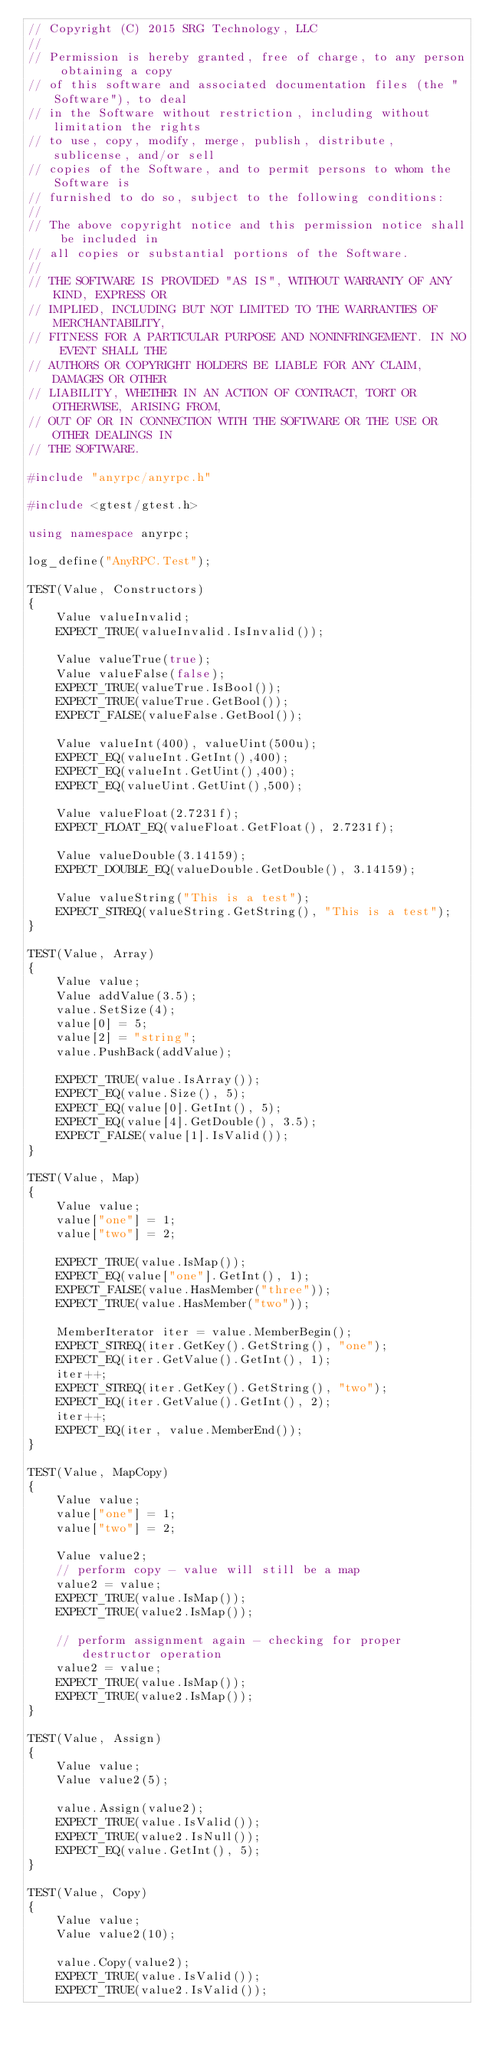Convert code to text. <code><loc_0><loc_0><loc_500><loc_500><_C++_>// Copyright (C) 2015 SRG Technology, LLC
//
// Permission is hereby granted, free of charge, to any person obtaining a copy
// of this software and associated documentation files (the "Software"), to deal
// in the Software without restriction, including without limitation the rights
// to use, copy, modify, merge, publish, distribute, sublicense, and/or sell
// copies of the Software, and to permit persons to whom the Software is
// furnished to do so, subject to the following conditions:
//
// The above copyright notice and this permission notice shall be included in
// all copies or substantial portions of the Software.
//
// THE SOFTWARE IS PROVIDED "AS IS", WITHOUT WARRANTY OF ANY KIND, EXPRESS OR
// IMPLIED, INCLUDING BUT NOT LIMITED TO THE WARRANTIES OF MERCHANTABILITY,
// FITNESS FOR A PARTICULAR PURPOSE AND NONINFRINGEMENT. IN NO EVENT SHALL THE
// AUTHORS OR COPYRIGHT HOLDERS BE LIABLE FOR ANY CLAIM, DAMAGES OR OTHER
// LIABILITY, WHETHER IN AN ACTION OF CONTRACT, TORT OR OTHERWISE, ARISING FROM,
// OUT OF OR IN CONNECTION WITH THE SOFTWARE OR THE USE OR OTHER DEALINGS IN
// THE SOFTWARE.

#include "anyrpc/anyrpc.h"

#include <gtest/gtest.h>

using namespace anyrpc;

log_define("AnyRPC.Test");

TEST(Value, Constructors)
{
    Value valueInvalid;
    EXPECT_TRUE(valueInvalid.IsInvalid());

    Value valueTrue(true);
    Value valueFalse(false);
    EXPECT_TRUE(valueTrue.IsBool());
    EXPECT_TRUE(valueTrue.GetBool());
    EXPECT_FALSE(valueFalse.GetBool());

    Value valueInt(400), valueUint(500u);
    EXPECT_EQ(valueInt.GetInt(),400);
    EXPECT_EQ(valueInt.GetUint(),400);
    EXPECT_EQ(valueUint.GetUint(),500);

    Value valueFloat(2.7231f);
    EXPECT_FLOAT_EQ(valueFloat.GetFloat(), 2.7231f);

    Value valueDouble(3.14159);
    EXPECT_DOUBLE_EQ(valueDouble.GetDouble(), 3.14159);

    Value valueString("This is a test");
    EXPECT_STREQ(valueString.GetString(), "This is a test");
}

TEST(Value, Array)
{
    Value value;
    Value addValue(3.5);
    value.SetSize(4);
    value[0] = 5;
    value[2] = "string";
    value.PushBack(addValue);

    EXPECT_TRUE(value.IsArray());
    EXPECT_EQ(value.Size(), 5);
    EXPECT_EQ(value[0].GetInt(), 5);
    EXPECT_EQ(value[4].GetDouble(), 3.5);
    EXPECT_FALSE(value[1].IsValid());
}

TEST(Value, Map)
{
    Value value;
    value["one"] = 1;
    value["two"] = 2;

    EXPECT_TRUE(value.IsMap());
    EXPECT_EQ(value["one"].GetInt(), 1);
    EXPECT_FALSE(value.HasMember("three"));
    EXPECT_TRUE(value.HasMember("two"));

    MemberIterator iter = value.MemberBegin();
    EXPECT_STREQ(iter.GetKey().GetString(), "one");
    EXPECT_EQ(iter.GetValue().GetInt(), 1);
    iter++;
    EXPECT_STREQ(iter.GetKey().GetString(), "two");
    EXPECT_EQ(iter.GetValue().GetInt(), 2);
    iter++;
    EXPECT_EQ(iter, value.MemberEnd());
}

TEST(Value, MapCopy)
{
    Value value;
    value["one"] = 1;
    value["two"] = 2;

    Value value2;
    // perform copy - value will still be a map
    value2 = value;
    EXPECT_TRUE(value.IsMap());
    EXPECT_TRUE(value2.IsMap());

    // perform assignment again - checking for proper destructor operation
    value2 = value;
    EXPECT_TRUE(value.IsMap());
    EXPECT_TRUE(value2.IsMap());
}

TEST(Value, Assign)
{
    Value value;
    Value value2(5);

    value.Assign(value2);
    EXPECT_TRUE(value.IsValid());
    EXPECT_TRUE(value2.IsNull());
    EXPECT_EQ(value.GetInt(), 5);
}

TEST(Value, Copy)
{
    Value value;
    Value value2(10);

    value.Copy(value2);
    EXPECT_TRUE(value.IsValid());
    EXPECT_TRUE(value2.IsValid());</code> 